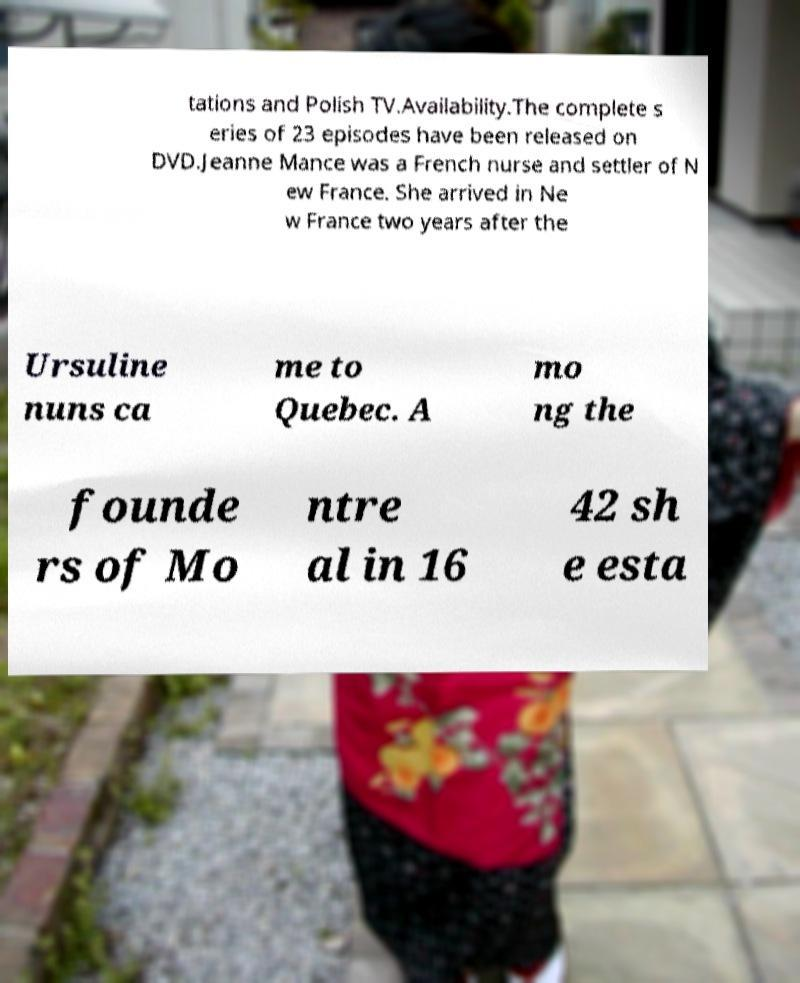What messages or text are displayed in this image? I need them in a readable, typed format. tations and Polish TV.Availability.The complete s eries of 23 episodes have been released on DVD.Jeanne Mance was a French nurse and settler of N ew France. She arrived in Ne w France two years after the Ursuline nuns ca me to Quebec. A mo ng the founde rs of Mo ntre al in 16 42 sh e esta 